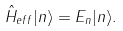Convert formula to latex. <formula><loc_0><loc_0><loc_500><loc_500>\hat { H } _ { e f f } | n \rangle = E _ { n } | n \rangle .</formula> 